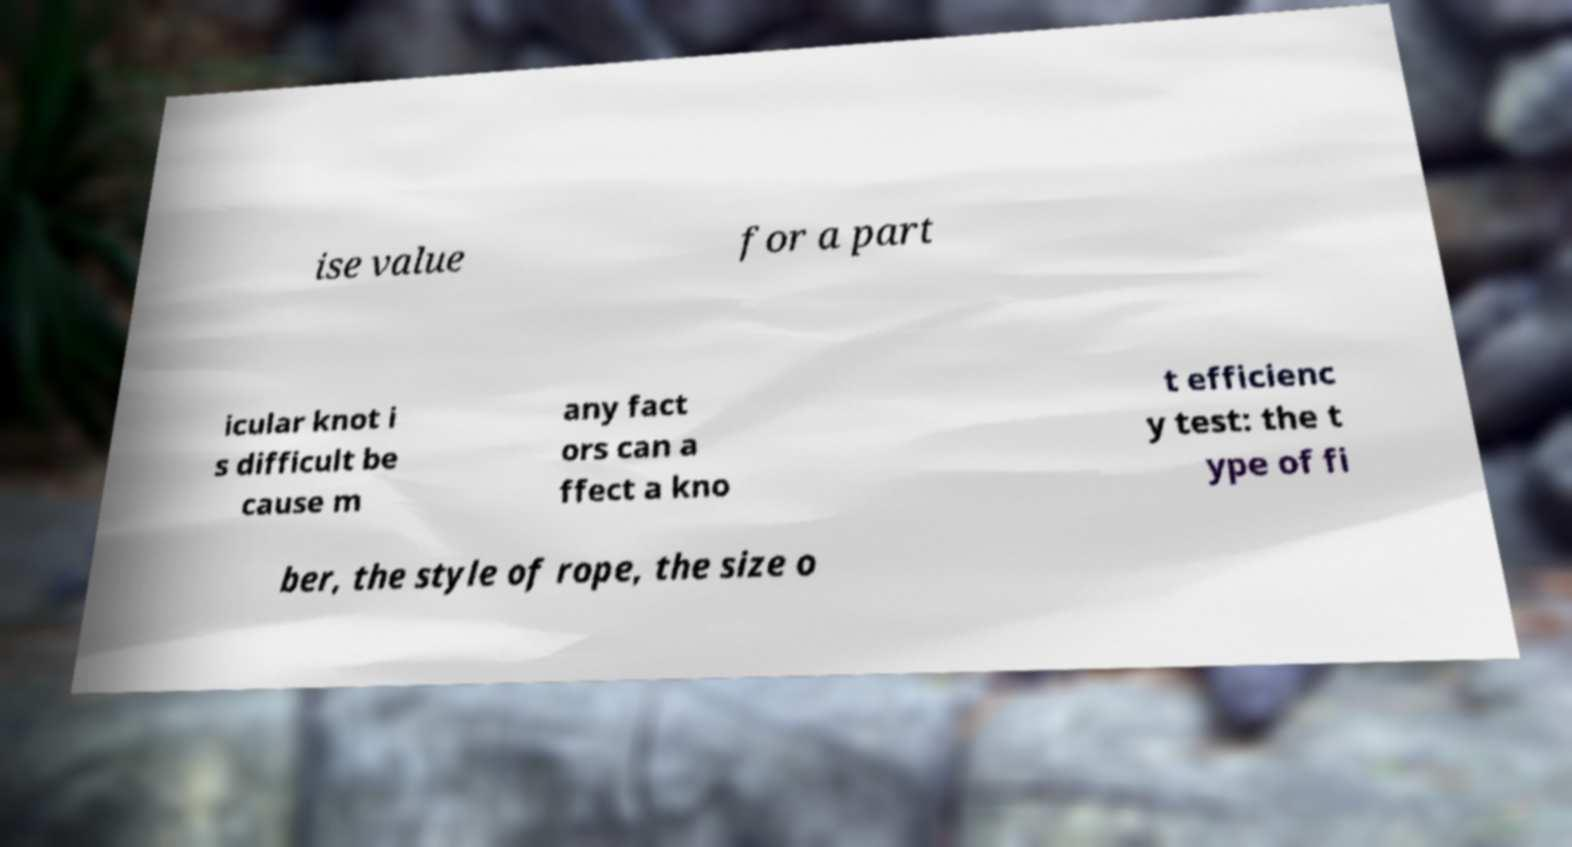Please read and relay the text visible in this image. What does it say? ise value for a part icular knot i s difficult be cause m any fact ors can a ffect a kno t efficienc y test: the t ype of fi ber, the style of rope, the size o 